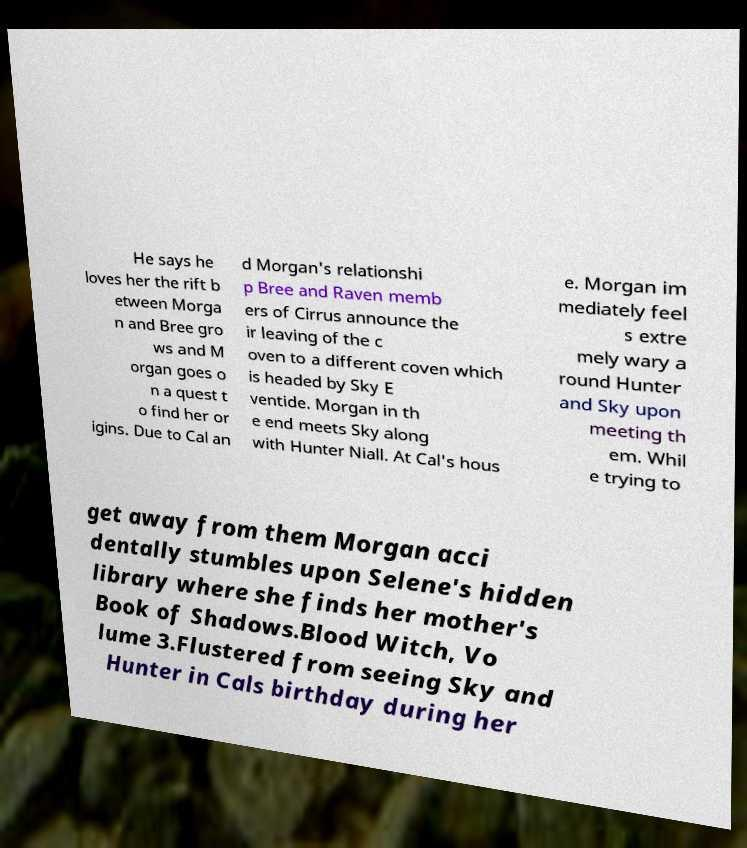For documentation purposes, I need the text within this image transcribed. Could you provide that? He says he loves her the rift b etween Morga n and Bree gro ws and M organ goes o n a quest t o find her or igins. Due to Cal an d Morgan's relationshi p Bree and Raven memb ers of Cirrus announce the ir leaving of the c oven to a different coven which is headed by Sky E ventide. Morgan in th e end meets Sky along with Hunter Niall. At Cal's hous e. Morgan im mediately feel s extre mely wary a round Hunter and Sky upon meeting th em. Whil e trying to get away from them Morgan acci dentally stumbles upon Selene's hidden library where she finds her mother's Book of Shadows.Blood Witch, Vo lume 3.Flustered from seeing Sky and Hunter in Cals birthday during her 